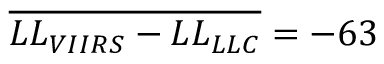<formula> <loc_0><loc_0><loc_500><loc_500>\overline { { L L _ { V I I R S } - L L _ { L L C } } } = - 6 3</formula> 